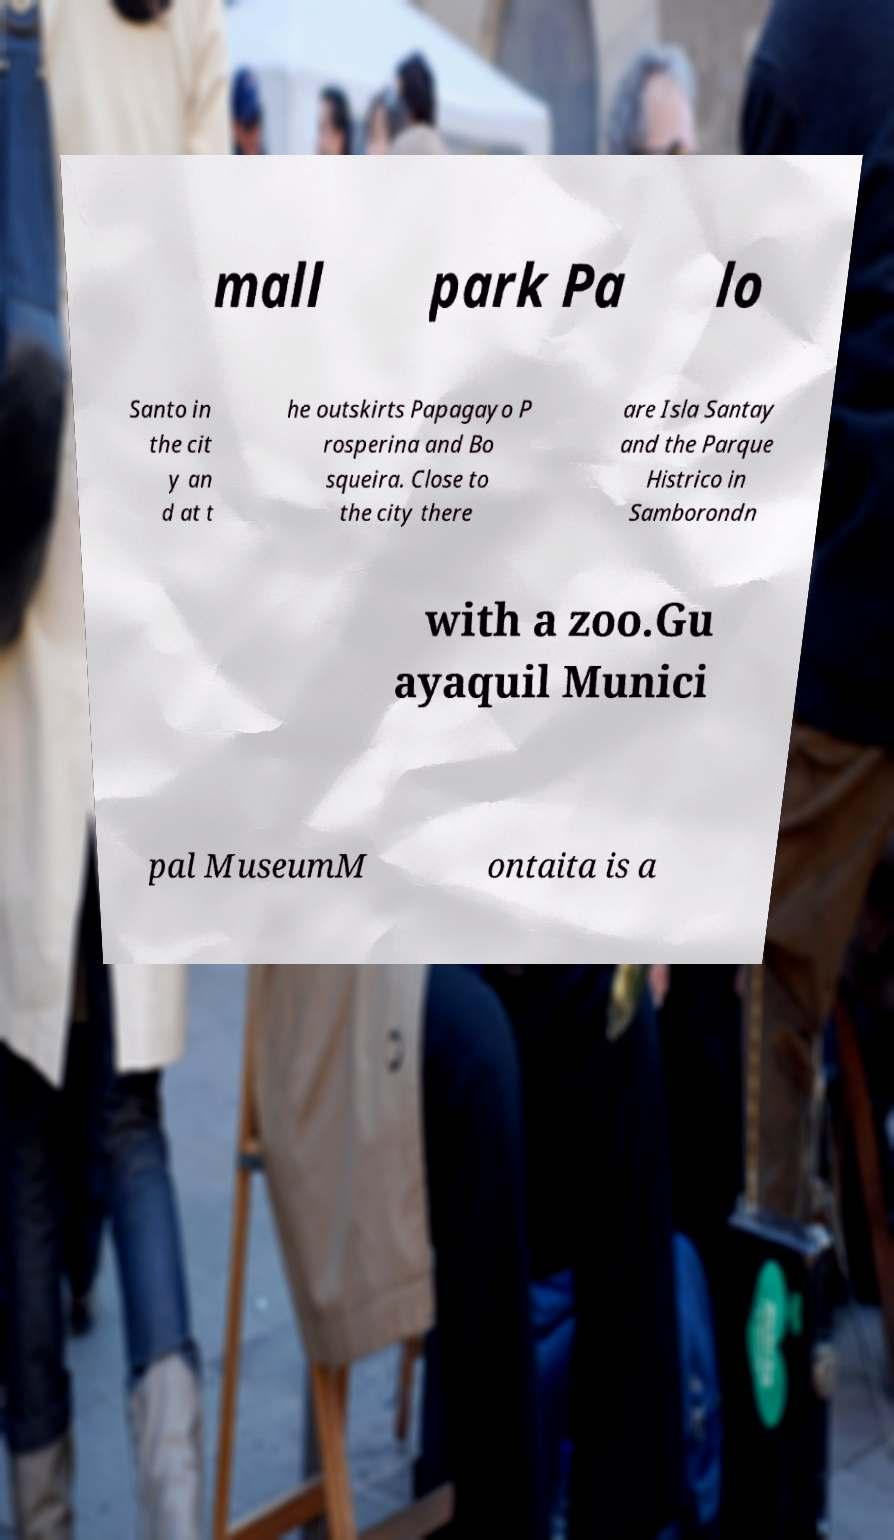Please read and relay the text visible in this image. What does it say? mall park Pa lo Santo in the cit y an d at t he outskirts Papagayo P rosperina and Bo squeira. Close to the city there are Isla Santay and the Parque Histrico in Samborondn with a zoo.Gu ayaquil Munici pal MuseumM ontaita is a 